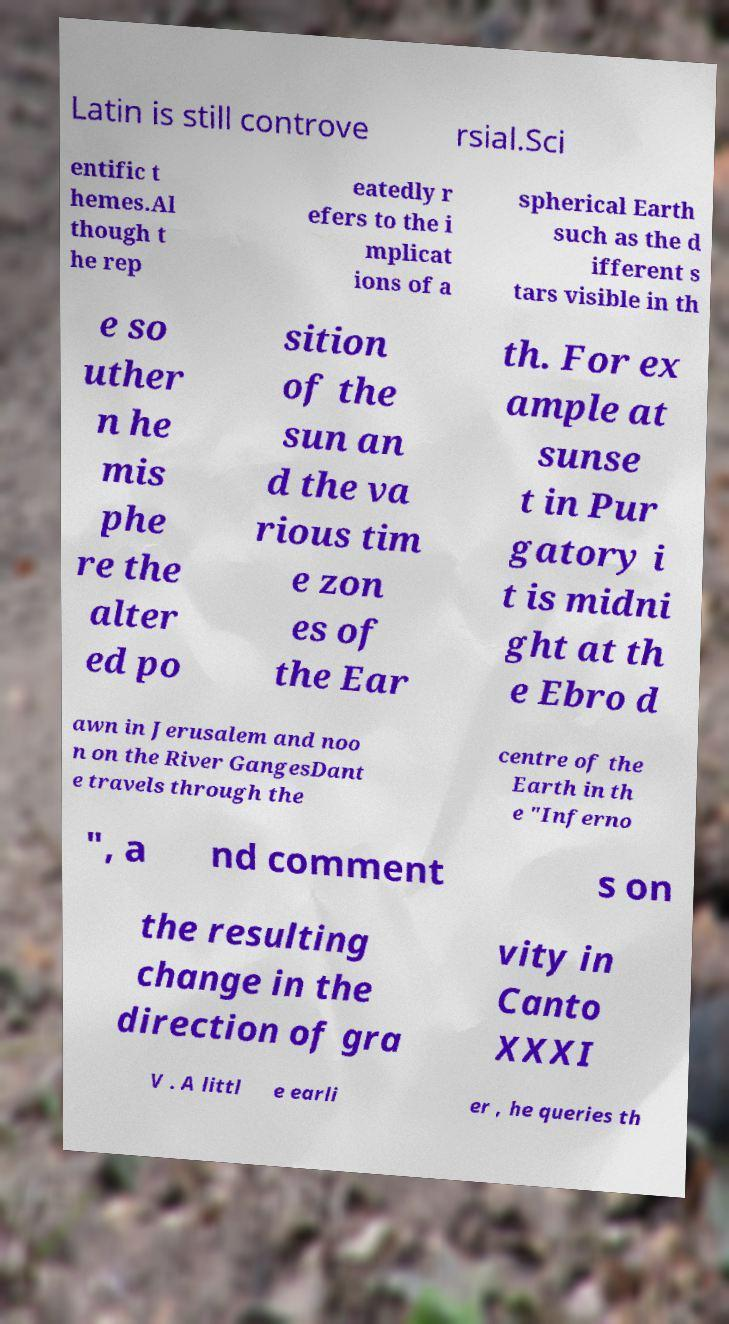Could you extract and type out the text from this image? Latin is still controve rsial.Sci entific t hemes.Al though t he rep eatedly r efers to the i mplicat ions of a spherical Earth such as the d ifferent s tars visible in th e so uther n he mis phe re the alter ed po sition of the sun an d the va rious tim e zon es of the Ear th. For ex ample at sunse t in Pur gatory i t is midni ght at th e Ebro d awn in Jerusalem and noo n on the River GangesDant e travels through the centre of the Earth in th e "Inferno ", a nd comment s on the resulting change in the direction of gra vity in Canto XXXI V . A littl e earli er , he queries th 